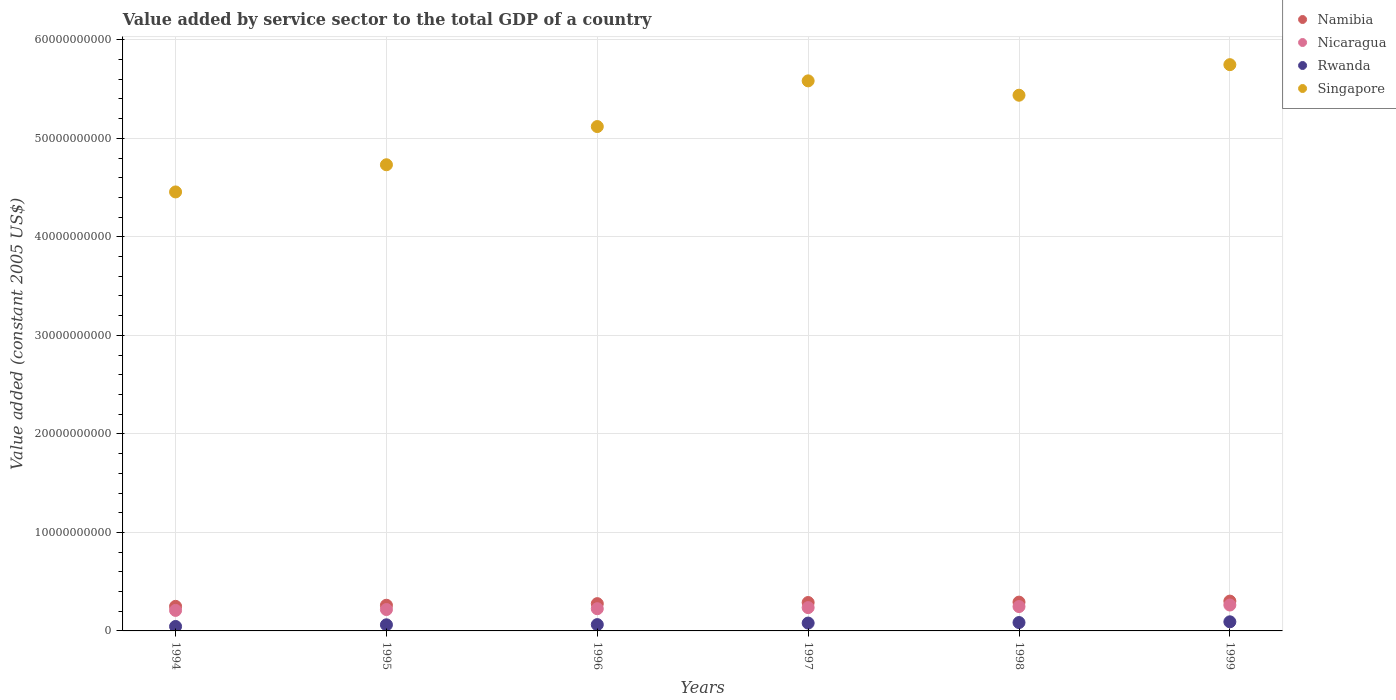How many different coloured dotlines are there?
Keep it short and to the point. 4. Is the number of dotlines equal to the number of legend labels?
Keep it short and to the point. Yes. What is the value added by service sector in Rwanda in 1994?
Offer a very short reply. 4.53e+08. Across all years, what is the maximum value added by service sector in Singapore?
Make the answer very short. 5.75e+1. Across all years, what is the minimum value added by service sector in Rwanda?
Ensure brevity in your answer.  4.53e+08. What is the total value added by service sector in Namibia in the graph?
Keep it short and to the point. 1.67e+1. What is the difference between the value added by service sector in Rwanda in 1998 and that in 1999?
Offer a terse response. -7.46e+07. What is the difference between the value added by service sector in Singapore in 1998 and the value added by service sector in Nicaragua in 1999?
Your answer should be very brief. 5.18e+1. What is the average value added by service sector in Rwanda per year?
Provide a succinct answer. 7.15e+08. In the year 1996, what is the difference between the value added by service sector in Singapore and value added by service sector in Rwanda?
Your answer should be compact. 5.06e+1. What is the ratio of the value added by service sector in Namibia in 1997 to that in 1999?
Your response must be concise. 0.95. What is the difference between the highest and the second highest value added by service sector in Singapore?
Make the answer very short. 1.64e+09. What is the difference between the highest and the lowest value added by service sector in Rwanda?
Provide a succinct answer. 4.72e+08. In how many years, is the value added by service sector in Nicaragua greater than the average value added by service sector in Nicaragua taken over all years?
Your response must be concise. 3. Is the sum of the value added by service sector in Namibia in 1995 and 1998 greater than the maximum value added by service sector in Nicaragua across all years?
Ensure brevity in your answer.  Yes. Is it the case that in every year, the sum of the value added by service sector in Namibia and value added by service sector in Rwanda  is greater than the sum of value added by service sector in Singapore and value added by service sector in Nicaragua?
Your answer should be compact. Yes. Does the value added by service sector in Rwanda monotonically increase over the years?
Offer a very short reply. Yes. Is the value added by service sector in Namibia strictly greater than the value added by service sector in Nicaragua over the years?
Make the answer very short. Yes. Is the value added by service sector in Rwanda strictly less than the value added by service sector in Singapore over the years?
Your response must be concise. Yes. How many dotlines are there?
Provide a succinct answer. 4. How many years are there in the graph?
Give a very brief answer. 6. What is the difference between two consecutive major ticks on the Y-axis?
Provide a short and direct response. 1.00e+1. Are the values on the major ticks of Y-axis written in scientific E-notation?
Provide a short and direct response. No. Does the graph contain any zero values?
Your answer should be very brief. No. How many legend labels are there?
Make the answer very short. 4. How are the legend labels stacked?
Provide a succinct answer. Vertical. What is the title of the graph?
Offer a very short reply. Value added by service sector to the total GDP of a country. Does "Niger" appear as one of the legend labels in the graph?
Offer a terse response. No. What is the label or title of the Y-axis?
Provide a succinct answer. Value added (constant 2005 US$). What is the Value added (constant 2005 US$) in Namibia in 1994?
Your answer should be very brief. 2.49e+09. What is the Value added (constant 2005 US$) of Nicaragua in 1994?
Your response must be concise. 2.08e+09. What is the Value added (constant 2005 US$) of Rwanda in 1994?
Your answer should be very brief. 4.53e+08. What is the Value added (constant 2005 US$) in Singapore in 1994?
Your answer should be very brief. 4.46e+1. What is the Value added (constant 2005 US$) in Namibia in 1995?
Provide a short and direct response. 2.61e+09. What is the Value added (constant 2005 US$) of Nicaragua in 1995?
Provide a succinct answer. 2.17e+09. What is the Value added (constant 2005 US$) of Rwanda in 1995?
Your answer should be very brief. 6.21e+08. What is the Value added (constant 2005 US$) in Singapore in 1995?
Your answer should be compact. 4.73e+1. What is the Value added (constant 2005 US$) in Namibia in 1996?
Ensure brevity in your answer.  2.77e+09. What is the Value added (constant 2005 US$) in Nicaragua in 1996?
Provide a short and direct response. 2.26e+09. What is the Value added (constant 2005 US$) in Rwanda in 1996?
Ensure brevity in your answer.  6.41e+08. What is the Value added (constant 2005 US$) in Singapore in 1996?
Ensure brevity in your answer.  5.12e+1. What is the Value added (constant 2005 US$) of Namibia in 1997?
Your answer should be compact. 2.88e+09. What is the Value added (constant 2005 US$) of Nicaragua in 1997?
Keep it short and to the point. 2.37e+09. What is the Value added (constant 2005 US$) of Rwanda in 1997?
Your response must be concise. 7.98e+08. What is the Value added (constant 2005 US$) in Singapore in 1997?
Give a very brief answer. 5.58e+1. What is the Value added (constant 2005 US$) in Namibia in 1998?
Offer a very short reply. 2.92e+09. What is the Value added (constant 2005 US$) of Nicaragua in 1998?
Your response must be concise. 2.47e+09. What is the Value added (constant 2005 US$) of Rwanda in 1998?
Your answer should be compact. 8.50e+08. What is the Value added (constant 2005 US$) of Singapore in 1998?
Provide a short and direct response. 5.44e+1. What is the Value added (constant 2005 US$) of Namibia in 1999?
Your response must be concise. 3.03e+09. What is the Value added (constant 2005 US$) in Nicaragua in 1999?
Offer a terse response. 2.63e+09. What is the Value added (constant 2005 US$) in Rwanda in 1999?
Give a very brief answer. 9.25e+08. What is the Value added (constant 2005 US$) in Singapore in 1999?
Your answer should be very brief. 5.75e+1. Across all years, what is the maximum Value added (constant 2005 US$) in Namibia?
Your answer should be compact. 3.03e+09. Across all years, what is the maximum Value added (constant 2005 US$) in Nicaragua?
Provide a short and direct response. 2.63e+09. Across all years, what is the maximum Value added (constant 2005 US$) of Rwanda?
Provide a succinct answer. 9.25e+08. Across all years, what is the maximum Value added (constant 2005 US$) of Singapore?
Provide a succinct answer. 5.75e+1. Across all years, what is the minimum Value added (constant 2005 US$) of Namibia?
Keep it short and to the point. 2.49e+09. Across all years, what is the minimum Value added (constant 2005 US$) in Nicaragua?
Provide a short and direct response. 2.08e+09. Across all years, what is the minimum Value added (constant 2005 US$) of Rwanda?
Keep it short and to the point. 4.53e+08. Across all years, what is the minimum Value added (constant 2005 US$) in Singapore?
Offer a very short reply. 4.46e+1. What is the total Value added (constant 2005 US$) of Namibia in the graph?
Provide a short and direct response. 1.67e+1. What is the total Value added (constant 2005 US$) of Nicaragua in the graph?
Give a very brief answer. 1.40e+1. What is the total Value added (constant 2005 US$) in Rwanda in the graph?
Make the answer very short. 4.29e+09. What is the total Value added (constant 2005 US$) in Singapore in the graph?
Your response must be concise. 3.11e+11. What is the difference between the Value added (constant 2005 US$) of Namibia in 1994 and that in 1995?
Your answer should be very brief. -1.13e+08. What is the difference between the Value added (constant 2005 US$) in Nicaragua in 1994 and that in 1995?
Provide a succinct answer. -8.71e+07. What is the difference between the Value added (constant 2005 US$) of Rwanda in 1994 and that in 1995?
Your response must be concise. -1.68e+08. What is the difference between the Value added (constant 2005 US$) of Singapore in 1994 and that in 1995?
Your answer should be compact. -2.76e+09. What is the difference between the Value added (constant 2005 US$) in Namibia in 1994 and that in 1996?
Your answer should be very brief. -2.74e+08. What is the difference between the Value added (constant 2005 US$) of Nicaragua in 1994 and that in 1996?
Keep it short and to the point. -1.72e+08. What is the difference between the Value added (constant 2005 US$) in Rwanda in 1994 and that in 1996?
Make the answer very short. -1.88e+08. What is the difference between the Value added (constant 2005 US$) of Singapore in 1994 and that in 1996?
Provide a succinct answer. -6.64e+09. What is the difference between the Value added (constant 2005 US$) in Namibia in 1994 and that in 1997?
Provide a short and direct response. -3.90e+08. What is the difference between the Value added (constant 2005 US$) of Nicaragua in 1994 and that in 1997?
Offer a terse response. -2.83e+08. What is the difference between the Value added (constant 2005 US$) in Rwanda in 1994 and that in 1997?
Your response must be concise. -3.45e+08. What is the difference between the Value added (constant 2005 US$) in Singapore in 1994 and that in 1997?
Provide a succinct answer. -1.13e+1. What is the difference between the Value added (constant 2005 US$) in Namibia in 1994 and that in 1998?
Your answer should be compact. -4.29e+08. What is the difference between the Value added (constant 2005 US$) of Nicaragua in 1994 and that in 1998?
Provide a short and direct response. -3.88e+08. What is the difference between the Value added (constant 2005 US$) in Rwanda in 1994 and that in 1998?
Provide a succinct answer. -3.97e+08. What is the difference between the Value added (constant 2005 US$) of Singapore in 1994 and that in 1998?
Provide a short and direct response. -9.82e+09. What is the difference between the Value added (constant 2005 US$) in Namibia in 1994 and that in 1999?
Make the answer very short. -5.33e+08. What is the difference between the Value added (constant 2005 US$) of Nicaragua in 1994 and that in 1999?
Provide a succinct answer. -5.45e+08. What is the difference between the Value added (constant 2005 US$) of Rwanda in 1994 and that in 1999?
Offer a terse response. -4.72e+08. What is the difference between the Value added (constant 2005 US$) in Singapore in 1994 and that in 1999?
Make the answer very short. -1.29e+1. What is the difference between the Value added (constant 2005 US$) in Namibia in 1995 and that in 1996?
Make the answer very short. -1.62e+08. What is the difference between the Value added (constant 2005 US$) in Nicaragua in 1995 and that in 1996?
Make the answer very short. -8.45e+07. What is the difference between the Value added (constant 2005 US$) in Rwanda in 1995 and that in 1996?
Your answer should be very brief. -1.95e+07. What is the difference between the Value added (constant 2005 US$) in Singapore in 1995 and that in 1996?
Your answer should be very brief. -3.88e+09. What is the difference between the Value added (constant 2005 US$) in Namibia in 1995 and that in 1997?
Your response must be concise. -2.77e+08. What is the difference between the Value added (constant 2005 US$) in Nicaragua in 1995 and that in 1997?
Provide a short and direct response. -1.96e+08. What is the difference between the Value added (constant 2005 US$) of Rwanda in 1995 and that in 1997?
Give a very brief answer. -1.76e+08. What is the difference between the Value added (constant 2005 US$) in Singapore in 1995 and that in 1997?
Provide a short and direct response. -8.52e+09. What is the difference between the Value added (constant 2005 US$) in Namibia in 1995 and that in 1998?
Offer a terse response. -3.16e+08. What is the difference between the Value added (constant 2005 US$) of Nicaragua in 1995 and that in 1998?
Keep it short and to the point. -3.01e+08. What is the difference between the Value added (constant 2005 US$) of Rwanda in 1995 and that in 1998?
Provide a succinct answer. -2.29e+08. What is the difference between the Value added (constant 2005 US$) of Singapore in 1995 and that in 1998?
Offer a terse response. -7.06e+09. What is the difference between the Value added (constant 2005 US$) of Namibia in 1995 and that in 1999?
Give a very brief answer. -4.20e+08. What is the difference between the Value added (constant 2005 US$) in Nicaragua in 1995 and that in 1999?
Keep it short and to the point. -4.58e+08. What is the difference between the Value added (constant 2005 US$) of Rwanda in 1995 and that in 1999?
Your answer should be very brief. -3.03e+08. What is the difference between the Value added (constant 2005 US$) of Singapore in 1995 and that in 1999?
Your answer should be compact. -1.02e+1. What is the difference between the Value added (constant 2005 US$) in Namibia in 1996 and that in 1997?
Provide a short and direct response. -1.15e+08. What is the difference between the Value added (constant 2005 US$) in Nicaragua in 1996 and that in 1997?
Ensure brevity in your answer.  -1.11e+08. What is the difference between the Value added (constant 2005 US$) in Rwanda in 1996 and that in 1997?
Ensure brevity in your answer.  -1.57e+08. What is the difference between the Value added (constant 2005 US$) in Singapore in 1996 and that in 1997?
Your response must be concise. -4.64e+09. What is the difference between the Value added (constant 2005 US$) of Namibia in 1996 and that in 1998?
Offer a very short reply. -1.54e+08. What is the difference between the Value added (constant 2005 US$) of Nicaragua in 1996 and that in 1998?
Offer a very short reply. -2.16e+08. What is the difference between the Value added (constant 2005 US$) of Rwanda in 1996 and that in 1998?
Your answer should be very brief. -2.09e+08. What is the difference between the Value added (constant 2005 US$) of Singapore in 1996 and that in 1998?
Provide a short and direct response. -3.18e+09. What is the difference between the Value added (constant 2005 US$) in Namibia in 1996 and that in 1999?
Your answer should be very brief. -2.58e+08. What is the difference between the Value added (constant 2005 US$) of Nicaragua in 1996 and that in 1999?
Your answer should be compact. -3.74e+08. What is the difference between the Value added (constant 2005 US$) of Rwanda in 1996 and that in 1999?
Keep it short and to the point. -2.84e+08. What is the difference between the Value added (constant 2005 US$) in Singapore in 1996 and that in 1999?
Provide a short and direct response. -6.28e+09. What is the difference between the Value added (constant 2005 US$) of Namibia in 1997 and that in 1998?
Provide a succinct answer. -3.89e+07. What is the difference between the Value added (constant 2005 US$) in Nicaragua in 1997 and that in 1998?
Your answer should be compact. -1.05e+08. What is the difference between the Value added (constant 2005 US$) of Rwanda in 1997 and that in 1998?
Offer a terse response. -5.24e+07. What is the difference between the Value added (constant 2005 US$) in Singapore in 1997 and that in 1998?
Make the answer very short. 1.46e+09. What is the difference between the Value added (constant 2005 US$) in Namibia in 1997 and that in 1999?
Your answer should be compact. -1.43e+08. What is the difference between the Value added (constant 2005 US$) in Nicaragua in 1997 and that in 1999?
Your answer should be very brief. -2.62e+08. What is the difference between the Value added (constant 2005 US$) in Rwanda in 1997 and that in 1999?
Keep it short and to the point. -1.27e+08. What is the difference between the Value added (constant 2005 US$) of Singapore in 1997 and that in 1999?
Your response must be concise. -1.64e+09. What is the difference between the Value added (constant 2005 US$) in Namibia in 1998 and that in 1999?
Your response must be concise. -1.04e+08. What is the difference between the Value added (constant 2005 US$) in Nicaragua in 1998 and that in 1999?
Ensure brevity in your answer.  -1.57e+08. What is the difference between the Value added (constant 2005 US$) of Rwanda in 1998 and that in 1999?
Your answer should be compact. -7.46e+07. What is the difference between the Value added (constant 2005 US$) in Singapore in 1998 and that in 1999?
Provide a short and direct response. -3.10e+09. What is the difference between the Value added (constant 2005 US$) of Namibia in 1994 and the Value added (constant 2005 US$) of Nicaragua in 1995?
Your response must be concise. 3.23e+08. What is the difference between the Value added (constant 2005 US$) in Namibia in 1994 and the Value added (constant 2005 US$) in Rwanda in 1995?
Your answer should be very brief. 1.87e+09. What is the difference between the Value added (constant 2005 US$) of Namibia in 1994 and the Value added (constant 2005 US$) of Singapore in 1995?
Provide a succinct answer. -4.48e+1. What is the difference between the Value added (constant 2005 US$) in Nicaragua in 1994 and the Value added (constant 2005 US$) in Rwanda in 1995?
Provide a short and direct response. 1.46e+09. What is the difference between the Value added (constant 2005 US$) of Nicaragua in 1994 and the Value added (constant 2005 US$) of Singapore in 1995?
Make the answer very short. -4.52e+1. What is the difference between the Value added (constant 2005 US$) in Rwanda in 1994 and the Value added (constant 2005 US$) in Singapore in 1995?
Make the answer very short. -4.69e+1. What is the difference between the Value added (constant 2005 US$) in Namibia in 1994 and the Value added (constant 2005 US$) in Nicaragua in 1996?
Make the answer very short. 2.39e+08. What is the difference between the Value added (constant 2005 US$) in Namibia in 1994 and the Value added (constant 2005 US$) in Rwanda in 1996?
Offer a very short reply. 1.85e+09. What is the difference between the Value added (constant 2005 US$) of Namibia in 1994 and the Value added (constant 2005 US$) of Singapore in 1996?
Make the answer very short. -4.87e+1. What is the difference between the Value added (constant 2005 US$) of Nicaragua in 1994 and the Value added (constant 2005 US$) of Rwanda in 1996?
Your answer should be very brief. 1.44e+09. What is the difference between the Value added (constant 2005 US$) of Nicaragua in 1994 and the Value added (constant 2005 US$) of Singapore in 1996?
Your answer should be compact. -4.91e+1. What is the difference between the Value added (constant 2005 US$) of Rwanda in 1994 and the Value added (constant 2005 US$) of Singapore in 1996?
Your response must be concise. -5.07e+1. What is the difference between the Value added (constant 2005 US$) in Namibia in 1994 and the Value added (constant 2005 US$) in Nicaragua in 1997?
Keep it short and to the point. 1.27e+08. What is the difference between the Value added (constant 2005 US$) of Namibia in 1994 and the Value added (constant 2005 US$) of Rwanda in 1997?
Keep it short and to the point. 1.70e+09. What is the difference between the Value added (constant 2005 US$) in Namibia in 1994 and the Value added (constant 2005 US$) in Singapore in 1997?
Your answer should be compact. -5.33e+1. What is the difference between the Value added (constant 2005 US$) of Nicaragua in 1994 and the Value added (constant 2005 US$) of Rwanda in 1997?
Make the answer very short. 1.29e+09. What is the difference between the Value added (constant 2005 US$) in Nicaragua in 1994 and the Value added (constant 2005 US$) in Singapore in 1997?
Your response must be concise. -5.38e+1. What is the difference between the Value added (constant 2005 US$) of Rwanda in 1994 and the Value added (constant 2005 US$) of Singapore in 1997?
Your answer should be very brief. -5.54e+1. What is the difference between the Value added (constant 2005 US$) in Namibia in 1994 and the Value added (constant 2005 US$) in Nicaragua in 1998?
Make the answer very short. 2.24e+07. What is the difference between the Value added (constant 2005 US$) of Namibia in 1994 and the Value added (constant 2005 US$) of Rwanda in 1998?
Your response must be concise. 1.64e+09. What is the difference between the Value added (constant 2005 US$) of Namibia in 1994 and the Value added (constant 2005 US$) of Singapore in 1998?
Keep it short and to the point. -5.19e+1. What is the difference between the Value added (constant 2005 US$) of Nicaragua in 1994 and the Value added (constant 2005 US$) of Rwanda in 1998?
Make the answer very short. 1.23e+09. What is the difference between the Value added (constant 2005 US$) of Nicaragua in 1994 and the Value added (constant 2005 US$) of Singapore in 1998?
Your answer should be compact. -5.23e+1. What is the difference between the Value added (constant 2005 US$) in Rwanda in 1994 and the Value added (constant 2005 US$) in Singapore in 1998?
Provide a succinct answer. -5.39e+1. What is the difference between the Value added (constant 2005 US$) in Namibia in 1994 and the Value added (constant 2005 US$) in Nicaragua in 1999?
Make the answer very short. -1.35e+08. What is the difference between the Value added (constant 2005 US$) in Namibia in 1994 and the Value added (constant 2005 US$) in Rwanda in 1999?
Give a very brief answer. 1.57e+09. What is the difference between the Value added (constant 2005 US$) of Namibia in 1994 and the Value added (constant 2005 US$) of Singapore in 1999?
Offer a very short reply. -5.50e+1. What is the difference between the Value added (constant 2005 US$) of Nicaragua in 1994 and the Value added (constant 2005 US$) of Rwanda in 1999?
Your answer should be very brief. 1.16e+09. What is the difference between the Value added (constant 2005 US$) in Nicaragua in 1994 and the Value added (constant 2005 US$) in Singapore in 1999?
Make the answer very short. -5.54e+1. What is the difference between the Value added (constant 2005 US$) of Rwanda in 1994 and the Value added (constant 2005 US$) of Singapore in 1999?
Make the answer very short. -5.70e+1. What is the difference between the Value added (constant 2005 US$) of Namibia in 1995 and the Value added (constant 2005 US$) of Nicaragua in 1996?
Give a very brief answer. 3.51e+08. What is the difference between the Value added (constant 2005 US$) in Namibia in 1995 and the Value added (constant 2005 US$) in Rwanda in 1996?
Keep it short and to the point. 1.97e+09. What is the difference between the Value added (constant 2005 US$) of Namibia in 1995 and the Value added (constant 2005 US$) of Singapore in 1996?
Offer a very short reply. -4.86e+1. What is the difference between the Value added (constant 2005 US$) in Nicaragua in 1995 and the Value added (constant 2005 US$) in Rwanda in 1996?
Make the answer very short. 1.53e+09. What is the difference between the Value added (constant 2005 US$) of Nicaragua in 1995 and the Value added (constant 2005 US$) of Singapore in 1996?
Your answer should be compact. -4.90e+1. What is the difference between the Value added (constant 2005 US$) of Rwanda in 1995 and the Value added (constant 2005 US$) of Singapore in 1996?
Give a very brief answer. -5.06e+1. What is the difference between the Value added (constant 2005 US$) in Namibia in 1995 and the Value added (constant 2005 US$) in Nicaragua in 1997?
Give a very brief answer. 2.40e+08. What is the difference between the Value added (constant 2005 US$) in Namibia in 1995 and the Value added (constant 2005 US$) in Rwanda in 1997?
Provide a short and direct response. 1.81e+09. What is the difference between the Value added (constant 2005 US$) in Namibia in 1995 and the Value added (constant 2005 US$) in Singapore in 1997?
Make the answer very short. -5.32e+1. What is the difference between the Value added (constant 2005 US$) of Nicaragua in 1995 and the Value added (constant 2005 US$) of Rwanda in 1997?
Keep it short and to the point. 1.37e+09. What is the difference between the Value added (constant 2005 US$) in Nicaragua in 1995 and the Value added (constant 2005 US$) in Singapore in 1997?
Offer a terse response. -5.37e+1. What is the difference between the Value added (constant 2005 US$) of Rwanda in 1995 and the Value added (constant 2005 US$) of Singapore in 1997?
Your answer should be very brief. -5.52e+1. What is the difference between the Value added (constant 2005 US$) of Namibia in 1995 and the Value added (constant 2005 US$) of Nicaragua in 1998?
Keep it short and to the point. 1.35e+08. What is the difference between the Value added (constant 2005 US$) of Namibia in 1995 and the Value added (constant 2005 US$) of Rwanda in 1998?
Make the answer very short. 1.76e+09. What is the difference between the Value added (constant 2005 US$) in Namibia in 1995 and the Value added (constant 2005 US$) in Singapore in 1998?
Ensure brevity in your answer.  -5.18e+1. What is the difference between the Value added (constant 2005 US$) in Nicaragua in 1995 and the Value added (constant 2005 US$) in Rwanda in 1998?
Your answer should be compact. 1.32e+09. What is the difference between the Value added (constant 2005 US$) of Nicaragua in 1995 and the Value added (constant 2005 US$) of Singapore in 1998?
Your response must be concise. -5.22e+1. What is the difference between the Value added (constant 2005 US$) in Rwanda in 1995 and the Value added (constant 2005 US$) in Singapore in 1998?
Make the answer very short. -5.38e+1. What is the difference between the Value added (constant 2005 US$) in Namibia in 1995 and the Value added (constant 2005 US$) in Nicaragua in 1999?
Offer a very short reply. -2.21e+07. What is the difference between the Value added (constant 2005 US$) of Namibia in 1995 and the Value added (constant 2005 US$) of Rwanda in 1999?
Keep it short and to the point. 1.68e+09. What is the difference between the Value added (constant 2005 US$) in Namibia in 1995 and the Value added (constant 2005 US$) in Singapore in 1999?
Keep it short and to the point. -5.49e+1. What is the difference between the Value added (constant 2005 US$) of Nicaragua in 1995 and the Value added (constant 2005 US$) of Rwanda in 1999?
Ensure brevity in your answer.  1.25e+09. What is the difference between the Value added (constant 2005 US$) of Nicaragua in 1995 and the Value added (constant 2005 US$) of Singapore in 1999?
Ensure brevity in your answer.  -5.53e+1. What is the difference between the Value added (constant 2005 US$) in Rwanda in 1995 and the Value added (constant 2005 US$) in Singapore in 1999?
Provide a short and direct response. -5.69e+1. What is the difference between the Value added (constant 2005 US$) of Namibia in 1996 and the Value added (constant 2005 US$) of Nicaragua in 1997?
Your answer should be compact. 4.02e+08. What is the difference between the Value added (constant 2005 US$) of Namibia in 1996 and the Value added (constant 2005 US$) of Rwanda in 1997?
Keep it short and to the point. 1.97e+09. What is the difference between the Value added (constant 2005 US$) of Namibia in 1996 and the Value added (constant 2005 US$) of Singapore in 1997?
Make the answer very short. -5.31e+1. What is the difference between the Value added (constant 2005 US$) of Nicaragua in 1996 and the Value added (constant 2005 US$) of Rwanda in 1997?
Your answer should be very brief. 1.46e+09. What is the difference between the Value added (constant 2005 US$) in Nicaragua in 1996 and the Value added (constant 2005 US$) in Singapore in 1997?
Make the answer very short. -5.36e+1. What is the difference between the Value added (constant 2005 US$) of Rwanda in 1996 and the Value added (constant 2005 US$) of Singapore in 1997?
Your answer should be very brief. -5.52e+1. What is the difference between the Value added (constant 2005 US$) in Namibia in 1996 and the Value added (constant 2005 US$) in Nicaragua in 1998?
Offer a terse response. 2.97e+08. What is the difference between the Value added (constant 2005 US$) of Namibia in 1996 and the Value added (constant 2005 US$) of Rwanda in 1998?
Ensure brevity in your answer.  1.92e+09. What is the difference between the Value added (constant 2005 US$) in Namibia in 1996 and the Value added (constant 2005 US$) in Singapore in 1998?
Make the answer very short. -5.16e+1. What is the difference between the Value added (constant 2005 US$) of Nicaragua in 1996 and the Value added (constant 2005 US$) of Rwanda in 1998?
Your answer should be very brief. 1.40e+09. What is the difference between the Value added (constant 2005 US$) in Nicaragua in 1996 and the Value added (constant 2005 US$) in Singapore in 1998?
Offer a terse response. -5.21e+1. What is the difference between the Value added (constant 2005 US$) of Rwanda in 1996 and the Value added (constant 2005 US$) of Singapore in 1998?
Keep it short and to the point. -5.37e+1. What is the difference between the Value added (constant 2005 US$) in Namibia in 1996 and the Value added (constant 2005 US$) in Nicaragua in 1999?
Ensure brevity in your answer.  1.40e+08. What is the difference between the Value added (constant 2005 US$) of Namibia in 1996 and the Value added (constant 2005 US$) of Rwanda in 1999?
Offer a very short reply. 1.84e+09. What is the difference between the Value added (constant 2005 US$) in Namibia in 1996 and the Value added (constant 2005 US$) in Singapore in 1999?
Provide a short and direct response. -5.47e+1. What is the difference between the Value added (constant 2005 US$) of Nicaragua in 1996 and the Value added (constant 2005 US$) of Rwanda in 1999?
Give a very brief answer. 1.33e+09. What is the difference between the Value added (constant 2005 US$) of Nicaragua in 1996 and the Value added (constant 2005 US$) of Singapore in 1999?
Ensure brevity in your answer.  -5.52e+1. What is the difference between the Value added (constant 2005 US$) of Rwanda in 1996 and the Value added (constant 2005 US$) of Singapore in 1999?
Provide a short and direct response. -5.68e+1. What is the difference between the Value added (constant 2005 US$) in Namibia in 1997 and the Value added (constant 2005 US$) in Nicaragua in 1998?
Your answer should be very brief. 4.12e+08. What is the difference between the Value added (constant 2005 US$) of Namibia in 1997 and the Value added (constant 2005 US$) of Rwanda in 1998?
Your response must be concise. 2.03e+09. What is the difference between the Value added (constant 2005 US$) of Namibia in 1997 and the Value added (constant 2005 US$) of Singapore in 1998?
Provide a succinct answer. -5.15e+1. What is the difference between the Value added (constant 2005 US$) of Nicaragua in 1997 and the Value added (constant 2005 US$) of Rwanda in 1998?
Your answer should be very brief. 1.52e+09. What is the difference between the Value added (constant 2005 US$) in Nicaragua in 1997 and the Value added (constant 2005 US$) in Singapore in 1998?
Make the answer very short. -5.20e+1. What is the difference between the Value added (constant 2005 US$) of Rwanda in 1997 and the Value added (constant 2005 US$) of Singapore in 1998?
Your answer should be compact. -5.36e+1. What is the difference between the Value added (constant 2005 US$) of Namibia in 1997 and the Value added (constant 2005 US$) of Nicaragua in 1999?
Your response must be concise. 2.55e+08. What is the difference between the Value added (constant 2005 US$) in Namibia in 1997 and the Value added (constant 2005 US$) in Rwanda in 1999?
Give a very brief answer. 1.96e+09. What is the difference between the Value added (constant 2005 US$) in Namibia in 1997 and the Value added (constant 2005 US$) in Singapore in 1999?
Offer a terse response. -5.46e+1. What is the difference between the Value added (constant 2005 US$) of Nicaragua in 1997 and the Value added (constant 2005 US$) of Rwanda in 1999?
Your answer should be very brief. 1.44e+09. What is the difference between the Value added (constant 2005 US$) of Nicaragua in 1997 and the Value added (constant 2005 US$) of Singapore in 1999?
Offer a terse response. -5.51e+1. What is the difference between the Value added (constant 2005 US$) in Rwanda in 1997 and the Value added (constant 2005 US$) in Singapore in 1999?
Your answer should be compact. -5.67e+1. What is the difference between the Value added (constant 2005 US$) in Namibia in 1998 and the Value added (constant 2005 US$) in Nicaragua in 1999?
Provide a short and direct response. 2.94e+08. What is the difference between the Value added (constant 2005 US$) in Namibia in 1998 and the Value added (constant 2005 US$) in Rwanda in 1999?
Offer a terse response. 2.00e+09. What is the difference between the Value added (constant 2005 US$) of Namibia in 1998 and the Value added (constant 2005 US$) of Singapore in 1999?
Your answer should be compact. -5.46e+1. What is the difference between the Value added (constant 2005 US$) in Nicaragua in 1998 and the Value added (constant 2005 US$) in Rwanda in 1999?
Provide a short and direct response. 1.55e+09. What is the difference between the Value added (constant 2005 US$) in Nicaragua in 1998 and the Value added (constant 2005 US$) in Singapore in 1999?
Keep it short and to the point. -5.50e+1. What is the difference between the Value added (constant 2005 US$) of Rwanda in 1998 and the Value added (constant 2005 US$) of Singapore in 1999?
Ensure brevity in your answer.  -5.66e+1. What is the average Value added (constant 2005 US$) in Namibia per year?
Offer a terse response. 2.78e+09. What is the average Value added (constant 2005 US$) in Nicaragua per year?
Ensure brevity in your answer.  2.33e+09. What is the average Value added (constant 2005 US$) in Rwanda per year?
Offer a very short reply. 7.15e+08. What is the average Value added (constant 2005 US$) of Singapore per year?
Provide a succinct answer. 5.18e+1. In the year 1994, what is the difference between the Value added (constant 2005 US$) in Namibia and Value added (constant 2005 US$) in Nicaragua?
Offer a terse response. 4.10e+08. In the year 1994, what is the difference between the Value added (constant 2005 US$) in Namibia and Value added (constant 2005 US$) in Rwanda?
Keep it short and to the point. 2.04e+09. In the year 1994, what is the difference between the Value added (constant 2005 US$) of Namibia and Value added (constant 2005 US$) of Singapore?
Offer a very short reply. -4.21e+1. In the year 1994, what is the difference between the Value added (constant 2005 US$) of Nicaragua and Value added (constant 2005 US$) of Rwanda?
Ensure brevity in your answer.  1.63e+09. In the year 1994, what is the difference between the Value added (constant 2005 US$) in Nicaragua and Value added (constant 2005 US$) in Singapore?
Make the answer very short. -4.25e+1. In the year 1994, what is the difference between the Value added (constant 2005 US$) in Rwanda and Value added (constant 2005 US$) in Singapore?
Give a very brief answer. -4.41e+1. In the year 1995, what is the difference between the Value added (constant 2005 US$) of Namibia and Value added (constant 2005 US$) of Nicaragua?
Your answer should be compact. 4.36e+08. In the year 1995, what is the difference between the Value added (constant 2005 US$) in Namibia and Value added (constant 2005 US$) in Rwanda?
Offer a very short reply. 1.99e+09. In the year 1995, what is the difference between the Value added (constant 2005 US$) in Namibia and Value added (constant 2005 US$) in Singapore?
Provide a short and direct response. -4.47e+1. In the year 1995, what is the difference between the Value added (constant 2005 US$) of Nicaragua and Value added (constant 2005 US$) of Rwanda?
Make the answer very short. 1.55e+09. In the year 1995, what is the difference between the Value added (constant 2005 US$) in Nicaragua and Value added (constant 2005 US$) in Singapore?
Keep it short and to the point. -4.52e+1. In the year 1995, what is the difference between the Value added (constant 2005 US$) in Rwanda and Value added (constant 2005 US$) in Singapore?
Offer a very short reply. -4.67e+1. In the year 1996, what is the difference between the Value added (constant 2005 US$) in Namibia and Value added (constant 2005 US$) in Nicaragua?
Your answer should be compact. 5.13e+08. In the year 1996, what is the difference between the Value added (constant 2005 US$) of Namibia and Value added (constant 2005 US$) of Rwanda?
Your answer should be very brief. 2.13e+09. In the year 1996, what is the difference between the Value added (constant 2005 US$) of Namibia and Value added (constant 2005 US$) of Singapore?
Your response must be concise. -4.84e+1. In the year 1996, what is the difference between the Value added (constant 2005 US$) of Nicaragua and Value added (constant 2005 US$) of Rwanda?
Your response must be concise. 1.61e+09. In the year 1996, what is the difference between the Value added (constant 2005 US$) of Nicaragua and Value added (constant 2005 US$) of Singapore?
Ensure brevity in your answer.  -4.89e+1. In the year 1996, what is the difference between the Value added (constant 2005 US$) in Rwanda and Value added (constant 2005 US$) in Singapore?
Your answer should be compact. -5.06e+1. In the year 1997, what is the difference between the Value added (constant 2005 US$) in Namibia and Value added (constant 2005 US$) in Nicaragua?
Keep it short and to the point. 5.17e+08. In the year 1997, what is the difference between the Value added (constant 2005 US$) in Namibia and Value added (constant 2005 US$) in Rwanda?
Offer a very short reply. 2.09e+09. In the year 1997, what is the difference between the Value added (constant 2005 US$) of Namibia and Value added (constant 2005 US$) of Singapore?
Give a very brief answer. -5.30e+1. In the year 1997, what is the difference between the Value added (constant 2005 US$) in Nicaragua and Value added (constant 2005 US$) in Rwanda?
Your answer should be very brief. 1.57e+09. In the year 1997, what is the difference between the Value added (constant 2005 US$) in Nicaragua and Value added (constant 2005 US$) in Singapore?
Ensure brevity in your answer.  -5.35e+1. In the year 1997, what is the difference between the Value added (constant 2005 US$) in Rwanda and Value added (constant 2005 US$) in Singapore?
Give a very brief answer. -5.50e+1. In the year 1998, what is the difference between the Value added (constant 2005 US$) in Namibia and Value added (constant 2005 US$) in Nicaragua?
Your answer should be compact. 4.51e+08. In the year 1998, what is the difference between the Value added (constant 2005 US$) of Namibia and Value added (constant 2005 US$) of Rwanda?
Provide a succinct answer. 2.07e+09. In the year 1998, what is the difference between the Value added (constant 2005 US$) of Namibia and Value added (constant 2005 US$) of Singapore?
Make the answer very short. -5.15e+1. In the year 1998, what is the difference between the Value added (constant 2005 US$) in Nicaragua and Value added (constant 2005 US$) in Rwanda?
Offer a very short reply. 1.62e+09. In the year 1998, what is the difference between the Value added (constant 2005 US$) in Nicaragua and Value added (constant 2005 US$) in Singapore?
Keep it short and to the point. -5.19e+1. In the year 1998, what is the difference between the Value added (constant 2005 US$) of Rwanda and Value added (constant 2005 US$) of Singapore?
Keep it short and to the point. -5.35e+1. In the year 1999, what is the difference between the Value added (constant 2005 US$) of Namibia and Value added (constant 2005 US$) of Nicaragua?
Offer a terse response. 3.98e+08. In the year 1999, what is the difference between the Value added (constant 2005 US$) in Namibia and Value added (constant 2005 US$) in Rwanda?
Provide a short and direct response. 2.10e+09. In the year 1999, what is the difference between the Value added (constant 2005 US$) in Namibia and Value added (constant 2005 US$) in Singapore?
Ensure brevity in your answer.  -5.45e+1. In the year 1999, what is the difference between the Value added (constant 2005 US$) of Nicaragua and Value added (constant 2005 US$) of Rwanda?
Offer a terse response. 1.70e+09. In the year 1999, what is the difference between the Value added (constant 2005 US$) of Nicaragua and Value added (constant 2005 US$) of Singapore?
Keep it short and to the point. -5.49e+1. In the year 1999, what is the difference between the Value added (constant 2005 US$) of Rwanda and Value added (constant 2005 US$) of Singapore?
Offer a very short reply. -5.66e+1. What is the ratio of the Value added (constant 2005 US$) of Namibia in 1994 to that in 1995?
Offer a very short reply. 0.96. What is the ratio of the Value added (constant 2005 US$) in Nicaragua in 1994 to that in 1995?
Make the answer very short. 0.96. What is the ratio of the Value added (constant 2005 US$) in Rwanda in 1994 to that in 1995?
Give a very brief answer. 0.73. What is the ratio of the Value added (constant 2005 US$) of Singapore in 1994 to that in 1995?
Your answer should be very brief. 0.94. What is the ratio of the Value added (constant 2005 US$) in Namibia in 1994 to that in 1996?
Give a very brief answer. 0.9. What is the ratio of the Value added (constant 2005 US$) of Nicaragua in 1994 to that in 1996?
Give a very brief answer. 0.92. What is the ratio of the Value added (constant 2005 US$) in Rwanda in 1994 to that in 1996?
Your answer should be compact. 0.71. What is the ratio of the Value added (constant 2005 US$) of Singapore in 1994 to that in 1996?
Provide a succinct answer. 0.87. What is the ratio of the Value added (constant 2005 US$) in Namibia in 1994 to that in 1997?
Provide a short and direct response. 0.86. What is the ratio of the Value added (constant 2005 US$) in Nicaragua in 1994 to that in 1997?
Keep it short and to the point. 0.88. What is the ratio of the Value added (constant 2005 US$) of Rwanda in 1994 to that in 1997?
Keep it short and to the point. 0.57. What is the ratio of the Value added (constant 2005 US$) of Singapore in 1994 to that in 1997?
Your response must be concise. 0.8. What is the ratio of the Value added (constant 2005 US$) of Namibia in 1994 to that in 1998?
Offer a very short reply. 0.85. What is the ratio of the Value added (constant 2005 US$) in Nicaragua in 1994 to that in 1998?
Ensure brevity in your answer.  0.84. What is the ratio of the Value added (constant 2005 US$) of Rwanda in 1994 to that in 1998?
Your answer should be very brief. 0.53. What is the ratio of the Value added (constant 2005 US$) of Singapore in 1994 to that in 1998?
Make the answer very short. 0.82. What is the ratio of the Value added (constant 2005 US$) of Namibia in 1994 to that in 1999?
Give a very brief answer. 0.82. What is the ratio of the Value added (constant 2005 US$) of Nicaragua in 1994 to that in 1999?
Provide a succinct answer. 0.79. What is the ratio of the Value added (constant 2005 US$) in Rwanda in 1994 to that in 1999?
Offer a very short reply. 0.49. What is the ratio of the Value added (constant 2005 US$) of Singapore in 1994 to that in 1999?
Your answer should be very brief. 0.78. What is the ratio of the Value added (constant 2005 US$) in Namibia in 1995 to that in 1996?
Make the answer very short. 0.94. What is the ratio of the Value added (constant 2005 US$) of Nicaragua in 1995 to that in 1996?
Your answer should be very brief. 0.96. What is the ratio of the Value added (constant 2005 US$) of Rwanda in 1995 to that in 1996?
Make the answer very short. 0.97. What is the ratio of the Value added (constant 2005 US$) in Singapore in 1995 to that in 1996?
Give a very brief answer. 0.92. What is the ratio of the Value added (constant 2005 US$) in Namibia in 1995 to that in 1997?
Give a very brief answer. 0.9. What is the ratio of the Value added (constant 2005 US$) in Nicaragua in 1995 to that in 1997?
Ensure brevity in your answer.  0.92. What is the ratio of the Value added (constant 2005 US$) of Rwanda in 1995 to that in 1997?
Make the answer very short. 0.78. What is the ratio of the Value added (constant 2005 US$) of Singapore in 1995 to that in 1997?
Give a very brief answer. 0.85. What is the ratio of the Value added (constant 2005 US$) of Namibia in 1995 to that in 1998?
Make the answer very short. 0.89. What is the ratio of the Value added (constant 2005 US$) of Nicaragua in 1995 to that in 1998?
Provide a succinct answer. 0.88. What is the ratio of the Value added (constant 2005 US$) of Rwanda in 1995 to that in 1998?
Offer a terse response. 0.73. What is the ratio of the Value added (constant 2005 US$) of Singapore in 1995 to that in 1998?
Provide a succinct answer. 0.87. What is the ratio of the Value added (constant 2005 US$) in Namibia in 1995 to that in 1999?
Offer a very short reply. 0.86. What is the ratio of the Value added (constant 2005 US$) of Nicaragua in 1995 to that in 1999?
Make the answer very short. 0.83. What is the ratio of the Value added (constant 2005 US$) in Rwanda in 1995 to that in 1999?
Ensure brevity in your answer.  0.67. What is the ratio of the Value added (constant 2005 US$) in Singapore in 1995 to that in 1999?
Provide a short and direct response. 0.82. What is the ratio of the Value added (constant 2005 US$) in Namibia in 1996 to that in 1997?
Your answer should be compact. 0.96. What is the ratio of the Value added (constant 2005 US$) in Nicaragua in 1996 to that in 1997?
Give a very brief answer. 0.95. What is the ratio of the Value added (constant 2005 US$) of Rwanda in 1996 to that in 1997?
Ensure brevity in your answer.  0.8. What is the ratio of the Value added (constant 2005 US$) in Singapore in 1996 to that in 1997?
Offer a very short reply. 0.92. What is the ratio of the Value added (constant 2005 US$) of Namibia in 1996 to that in 1998?
Offer a terse response. 0.95. What is the ratio of the Value added (constant 2005 US$) of Nicaragua in 1996 to that in 1998?
Your answer should be compact. 0.91. What is the ratio of the Value added (constant 2005 US$) in Rwanda in 1996 to that in 1998?
Give a very brief answer. 0.75. What is the ratio of the Value added (constant 2005 US$) in Singapore in 1996 to that in 1998?
Make the answer very short. 0.94. What is the ratio of the Value added (constant 2005 US$) of Namibia in 1996 to that in 1999?
Your response must be concise. 0.91. What is the ratio of the Value added (constant 2005 US$) of Nicaragua in 1996 to that in 1999?
Provide a short and direct response. 0.86. What is the ratio of the Value added (constant 2005 US$) of Rwanda in 1996 to that in 1999?
Your answer should be compact. 0.69. What is the ratio of the Value added (constant 2005 US$) of Singapore in 1996 to that in 1999?
Your answer should be very brief. 0.89. What is the ratio of the Value added (constant 2005 US$) of Namibia in 1997 to that in 1998?
Give a very brief answer. 0.99. What is the ratio of the Value added (constant 2005 US$) in Nicaragua in 1997 to that in 1998?
Ensure brevity in your answer.  0.96. What is the ratio of the Value added (constant 2005 US$) of Rwanda in 1997 to that in 1998?
Provide a succinct answer. 0.94. What is the ratio of the Value added (constant 2005 US$) of Singapore in 1997 to that in 1998?
Keep it short and to the point. 1.03. What is the ratio of the Value added (constant 2005 US$) in Namibia in 1997 to that in 1999?
Make the answer very short. 0.95. What is the ratio of the Value added (constant 2005 US$) of Nicaragua in 1997 to that in 1999?
Offer a very short reply. 0.9. What is the ratio of the Value added (constant 2005 US$) in Rwanda in 1997 to that in 1999?
Provide a short and direct response. 0.86. What is the ratio of the Value added (constant 2005 US$) of Singapore in 1997 to that in 1999?
Provide a short and direct response. 0.97. What is the ratio of the Value added (constant 2005 US$) in Namibia in 1998 to that in 1999?
Offer a very short reply. 0.97. What is the ratio of the Value added (constant 2005 US$) of Nicaragua in 1998 to that in 1999?
Give a very brief answer. 0.94. What is the ratio of the Value added (constant 2005 US$) of Rwanda in 1998 to that in 1999?
Provide a short and direct response. 0.92. What is the ratio of the Value added (constant 2005 US$) of Singapore in 1998 to that in 1999?
Your answer should be very brief. 0.95. What is the difference between the highest and the second highest Value added (constant 2005 US$) in Namibia?
Your answer should be compact. 1.04e+08. What is the difference between the highest and the second highest Value added (constant 2005 US$) in Nicaragua?
Make the answer very short. 1.57e+08. What is the difference between the highest and the second highest Value added (constant 2005 US$) in Rwanda?
Give a very brief answer. 7.46e+07. What is the difference between the highest and the second highest Value added (constant 2005 US$) of Singapore?
Offer a very short reply. 1.64e+09. What is the difference between the highest and the lowest Value added (constant 2005 US$) of Namibia?
Your answer should be very brief. 5.33e+08. What is the difference between the highest and the lowest Value added (constant 2005 US$) in Nicaragua?
Offer a terse response. 5.45e+08. What is the difference between the highest and the lowest Value added (constant 2005 US$) in Rwanda?
Give a very brief answer. 4.72e+08. What is the difference between the highest and the lowest Value added (constant 2005 US$) of Singapore?
Provide a short and direct response. 1.29e+1. 